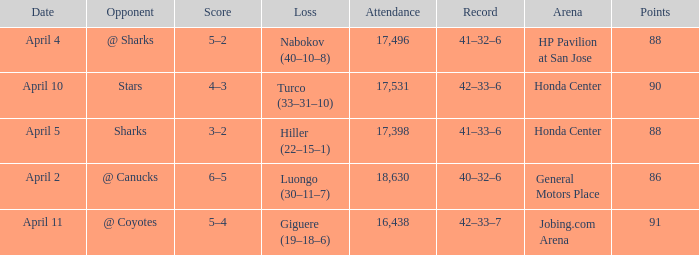How many Points have a Score of 3–2, and an Attendance larger than 17,398? None. 